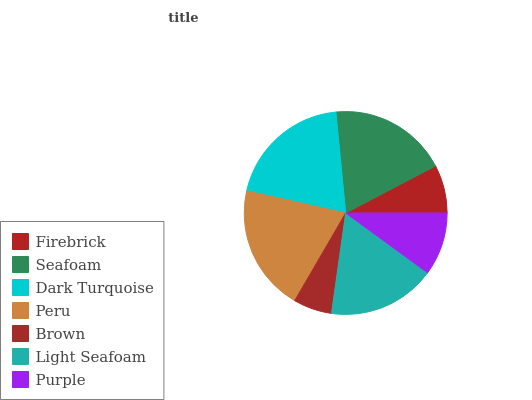Is Brown the minimum?
Answer yes or no. Yes. Is Peru the maximum?
Answer yes or no. Yes. Is Seafoam the minimum?
Answer yes or no. No. Is Seafoam the maximum?
Answer yes or no. No. Is Seafoam greater than Firebrick?
Answer yes or no. Yes. Is Firebrick less than Seafoam?
Answer yes or no. Yes. Is Firebrick greater than Seafoam?
Answer yes or no. No. Is Seafoam less than Firebrick?
Answer yes or no. No. Is Light Seafoam the high median?
Answer yes or no. Yes. Is Light Seafoam the low median?
Answer yes or no. Yes. Is Purple the high median?
Answer yes or no. No. Is Dark Turquoise the low median?
Answer yes or no. No. 